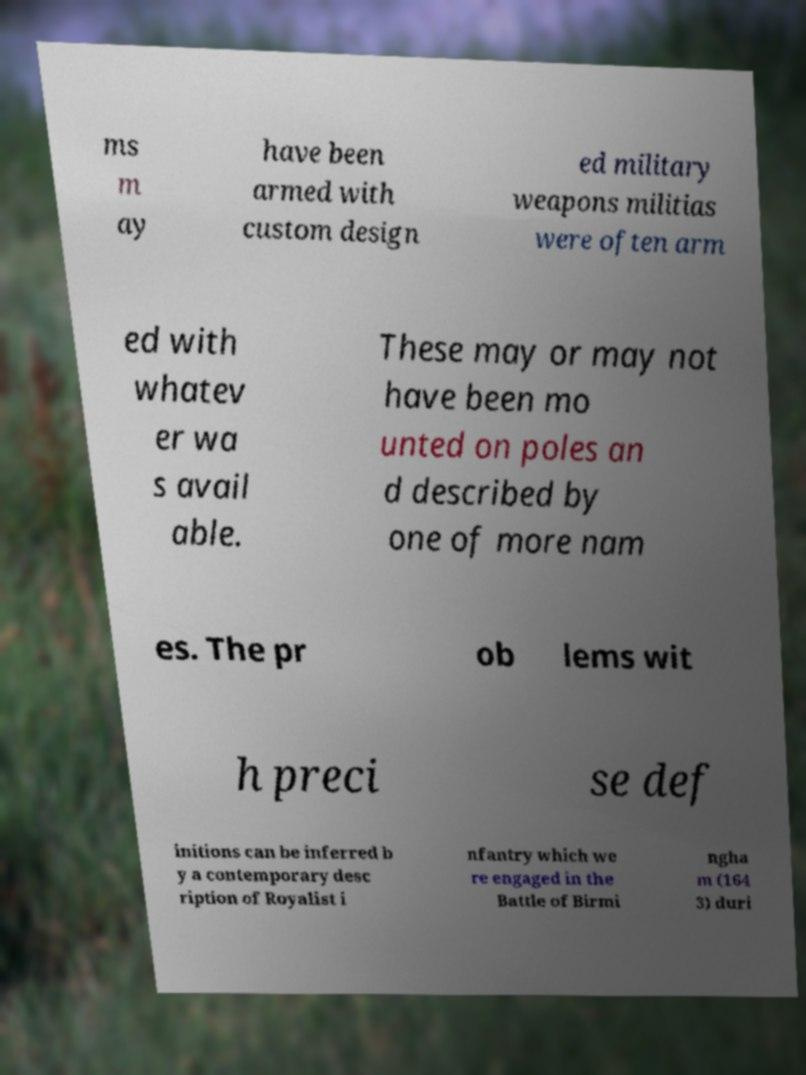What messages or text are displayed in this image? I need them in a readable, typed format. ms m ay have been armed with custom design ed military weapons militias were often arm ed with whatev er wa s avail able. These may or may not have been mo unted on poles an d described by one of more nam es. The pr ob lems wit h preci se def initions can be inferred b y a contemporary desc ription of Royalist i nfantry which we re engaged in the Battle of Birmi ngha m (164 3) duri 